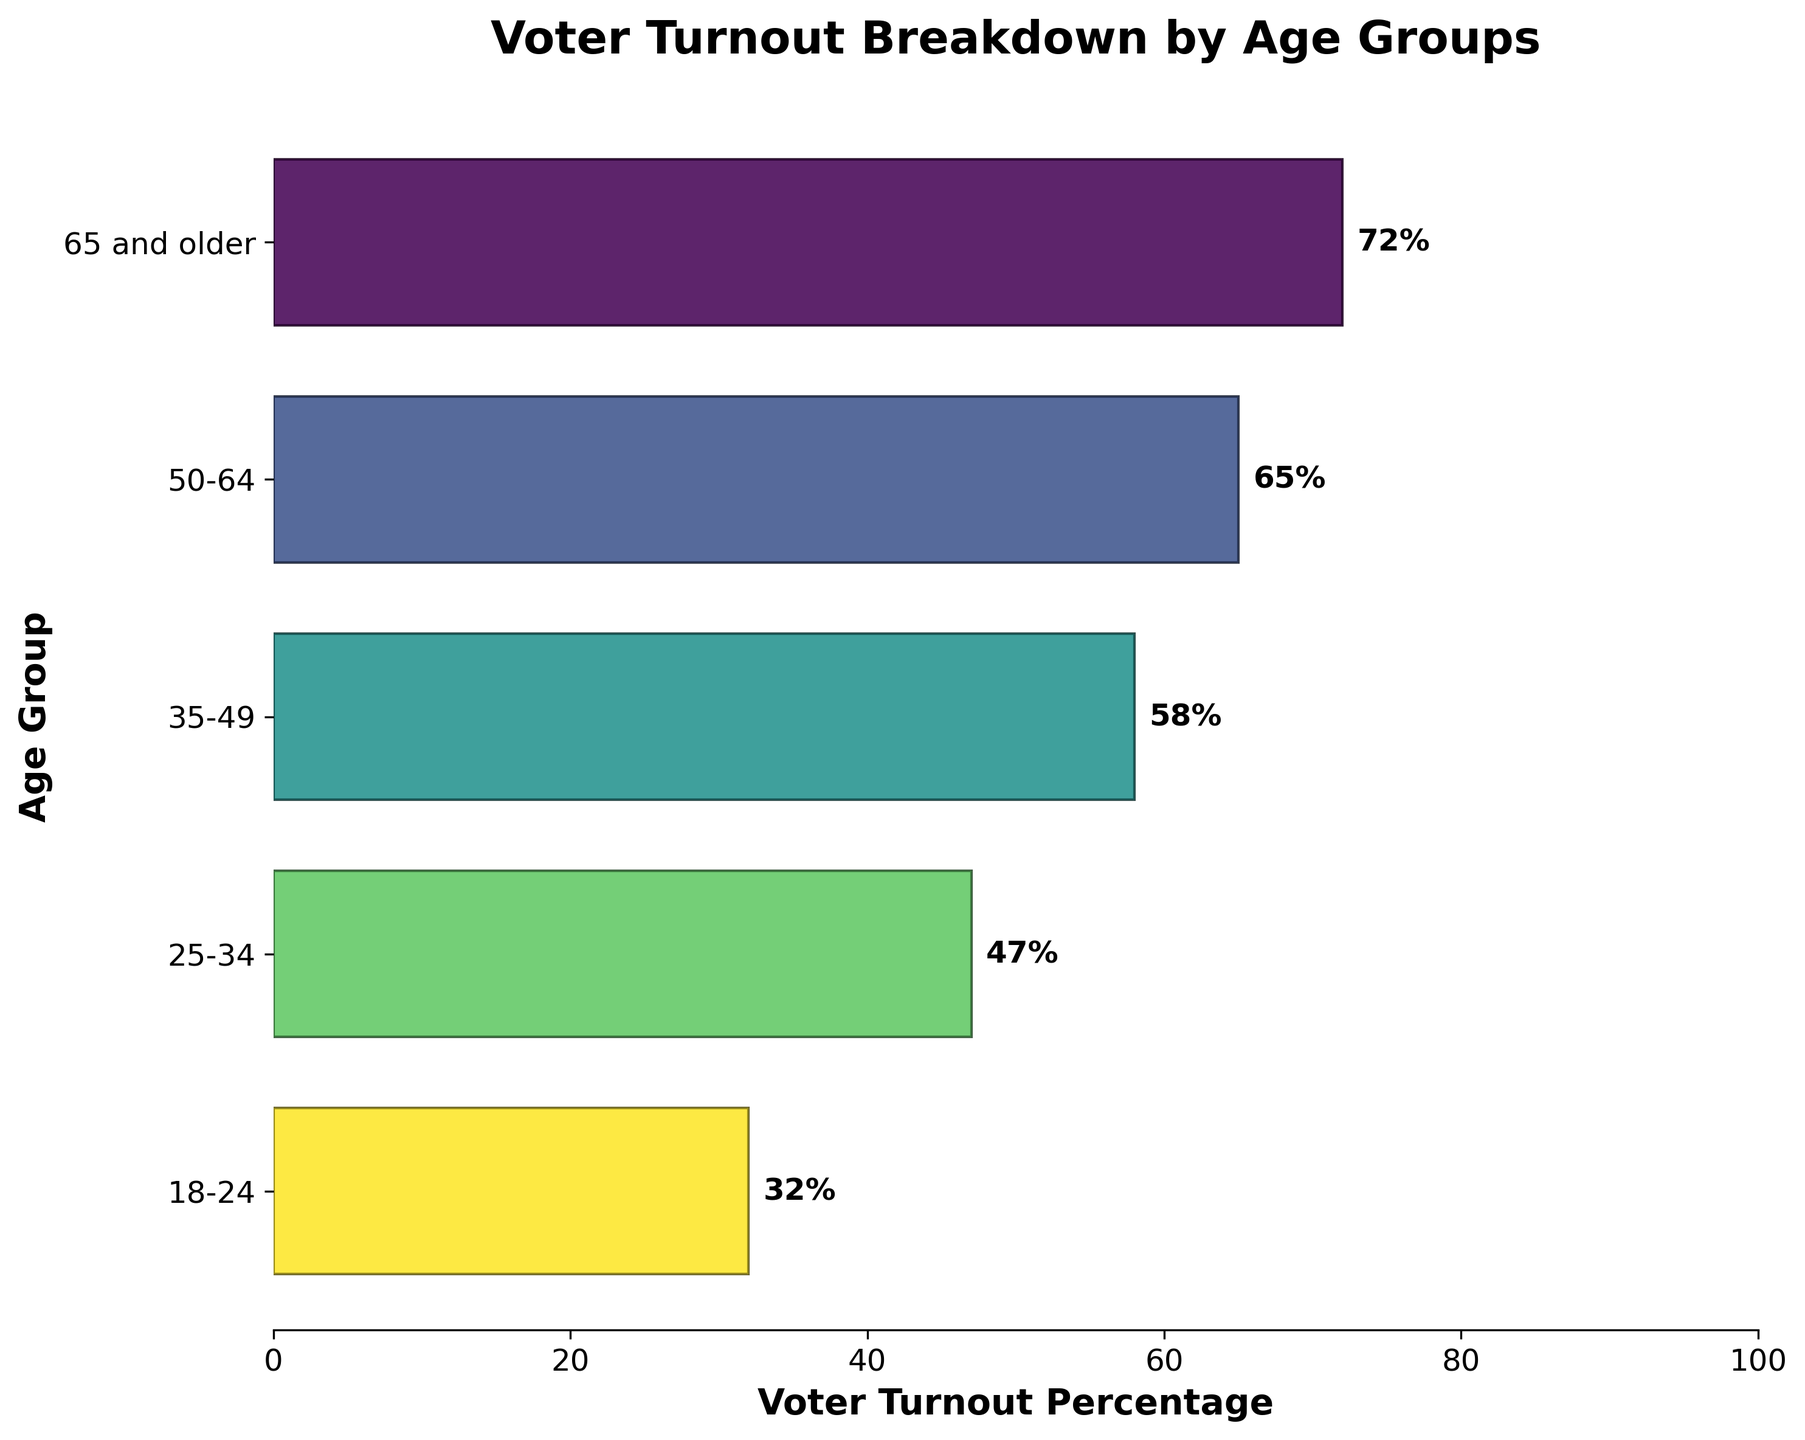What's the title of the figure? The title of the figure appears at the very top and reads "Voter Turnout Breakdown by Age Groups".
Answer: Voter Turnout Breakdown by Age Groups Which age group has the highest voter turnout percentage? The age group with the highest bar, located at the top, represents the group "65 and older" and shows a percentage of 72%.
Answer: 65 and older What's the difference in voter turnout percentage between the "18-24" age group and the "25-34" age group? The "25-34" age group has a voter turnout percentage of 47%, while the "18-24" age group has 32%. The difference is calculated by subtracting 32% from 47%.
Answer: 15% What is the median voter turnout percentage across all age groups? To find the median, sort the voter turnout percentages: 32%, 47%, 58%, 65%, 72%. The median is the middle value, which is 58%.
Answer: 58% By how much does the voter turnout percentage of the "50-64" age group exceed that of the "35-49" age group? The "50-64" age group has a turnout of 65%, and the "35-49" group has 58%. The difference between them is 65% - 58%.
Answer: 7% Identify two age groups whose combined voter turnout percentages equal that of the "65 and older" age group. The "65 and older" group has a 72% turnout. The "25-34" group has 47%, and "18-24" has 32%. Combined, they make 47% + 32% = 79%, which is more than 72%. The next combination to check is "35-49" with 58% and "18-24" with 32%, which gives 58% + 32% = 90%. Neither combination perfectly equals 72%.
Answer: None What's the average voter turnout percentage among all age groups? Sum all voter turnout percentages: 72% + 65% + 58% + 47% + 32% = 274. Divide by the number of groups, 5. So the average is 274 / 5.
Answer: 54.8% Which age group is closest to the average voter turnout percentage? The average turnout percentage is 54.8%. Compare each group's percentage to this value and find which one is closest. “35-49” age group has 58%, which is closest to 54.8%.
Answer: 35-49 Is there a trend in voter turnout percentage as the age group increases? Observing the bars from bottom to top, voter turnout percentage consistently increases with the age group.
Answer: Yes How much more likely are individuals aged 65 and older to vote compared to those aged 18-24? "65 and older" has a turnout of 72%, and "18-24" has 32%. Divide 72% by 32% to find how many times higher the turnout is. 72 / 32 = 2.25.
Answer: 2.25 times 